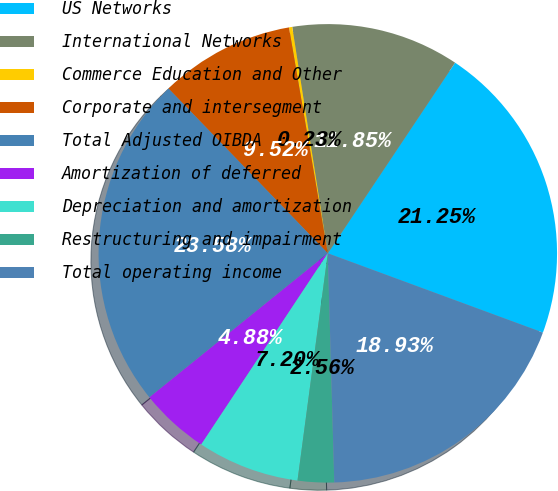Convert chart to OTSL. <chart><loc_0><loc_0><loc_500><loc_500><pie_chart><fcel>US Networks<fcel>International Networks<fcel>Commerce Education and Other<fcel>Corporate and intersegment<fcel>Total Adjusted OIBDA<fcel>Amortization of deferred<fcel>Depreciation and amortization<fcel>Restructuring and impairment<fcel>Total operating income<nl><fcel>21.25%<fcel>11.85%<fcel>0.23%<fcel>9.52%<fcel>23.58%<fcel>4.88%<fcel>7.2%<fcel>2.56%<fcel>18.93%<nl></chart> 